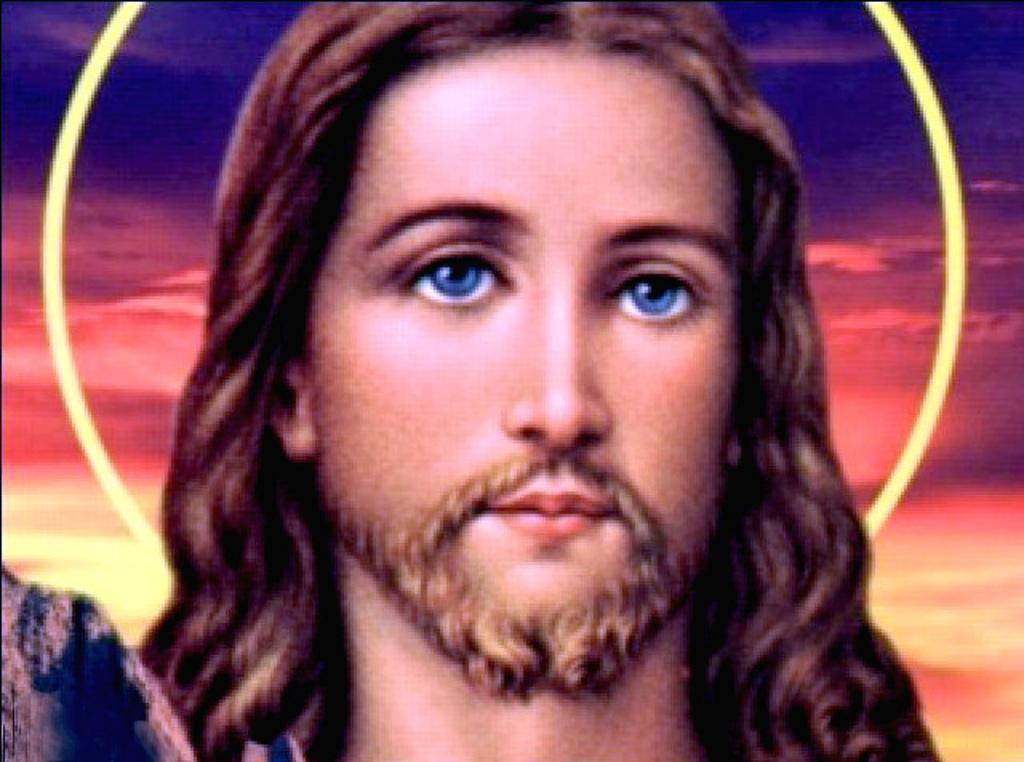How would you summarize this image in a sentence or two? In the center of the image there is a depiction of a person. 